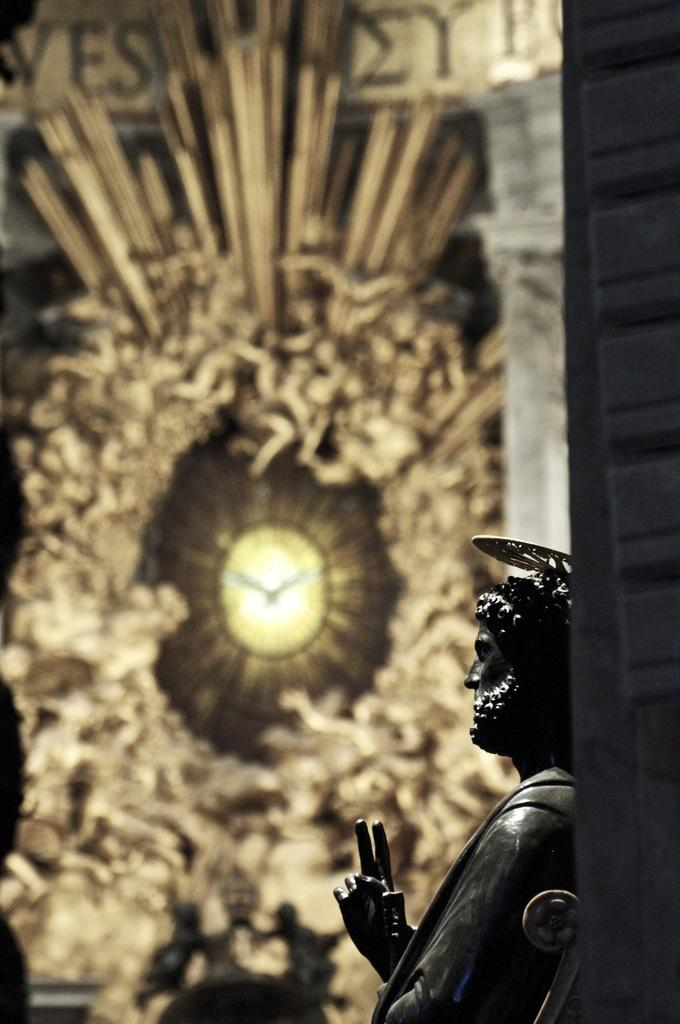What is the main subject of the image? There is a statue of a man in the image. What other object can be seen in the image? There is a clock in the image. How would you describe the background of the image? The background of the image is blurry. What type of design can be seen on the faucet in the image? There is no faucet present in the image. How many visitors are visible in the image? There are no visitors visible in the image; it only features a statue of a man and a clock. 